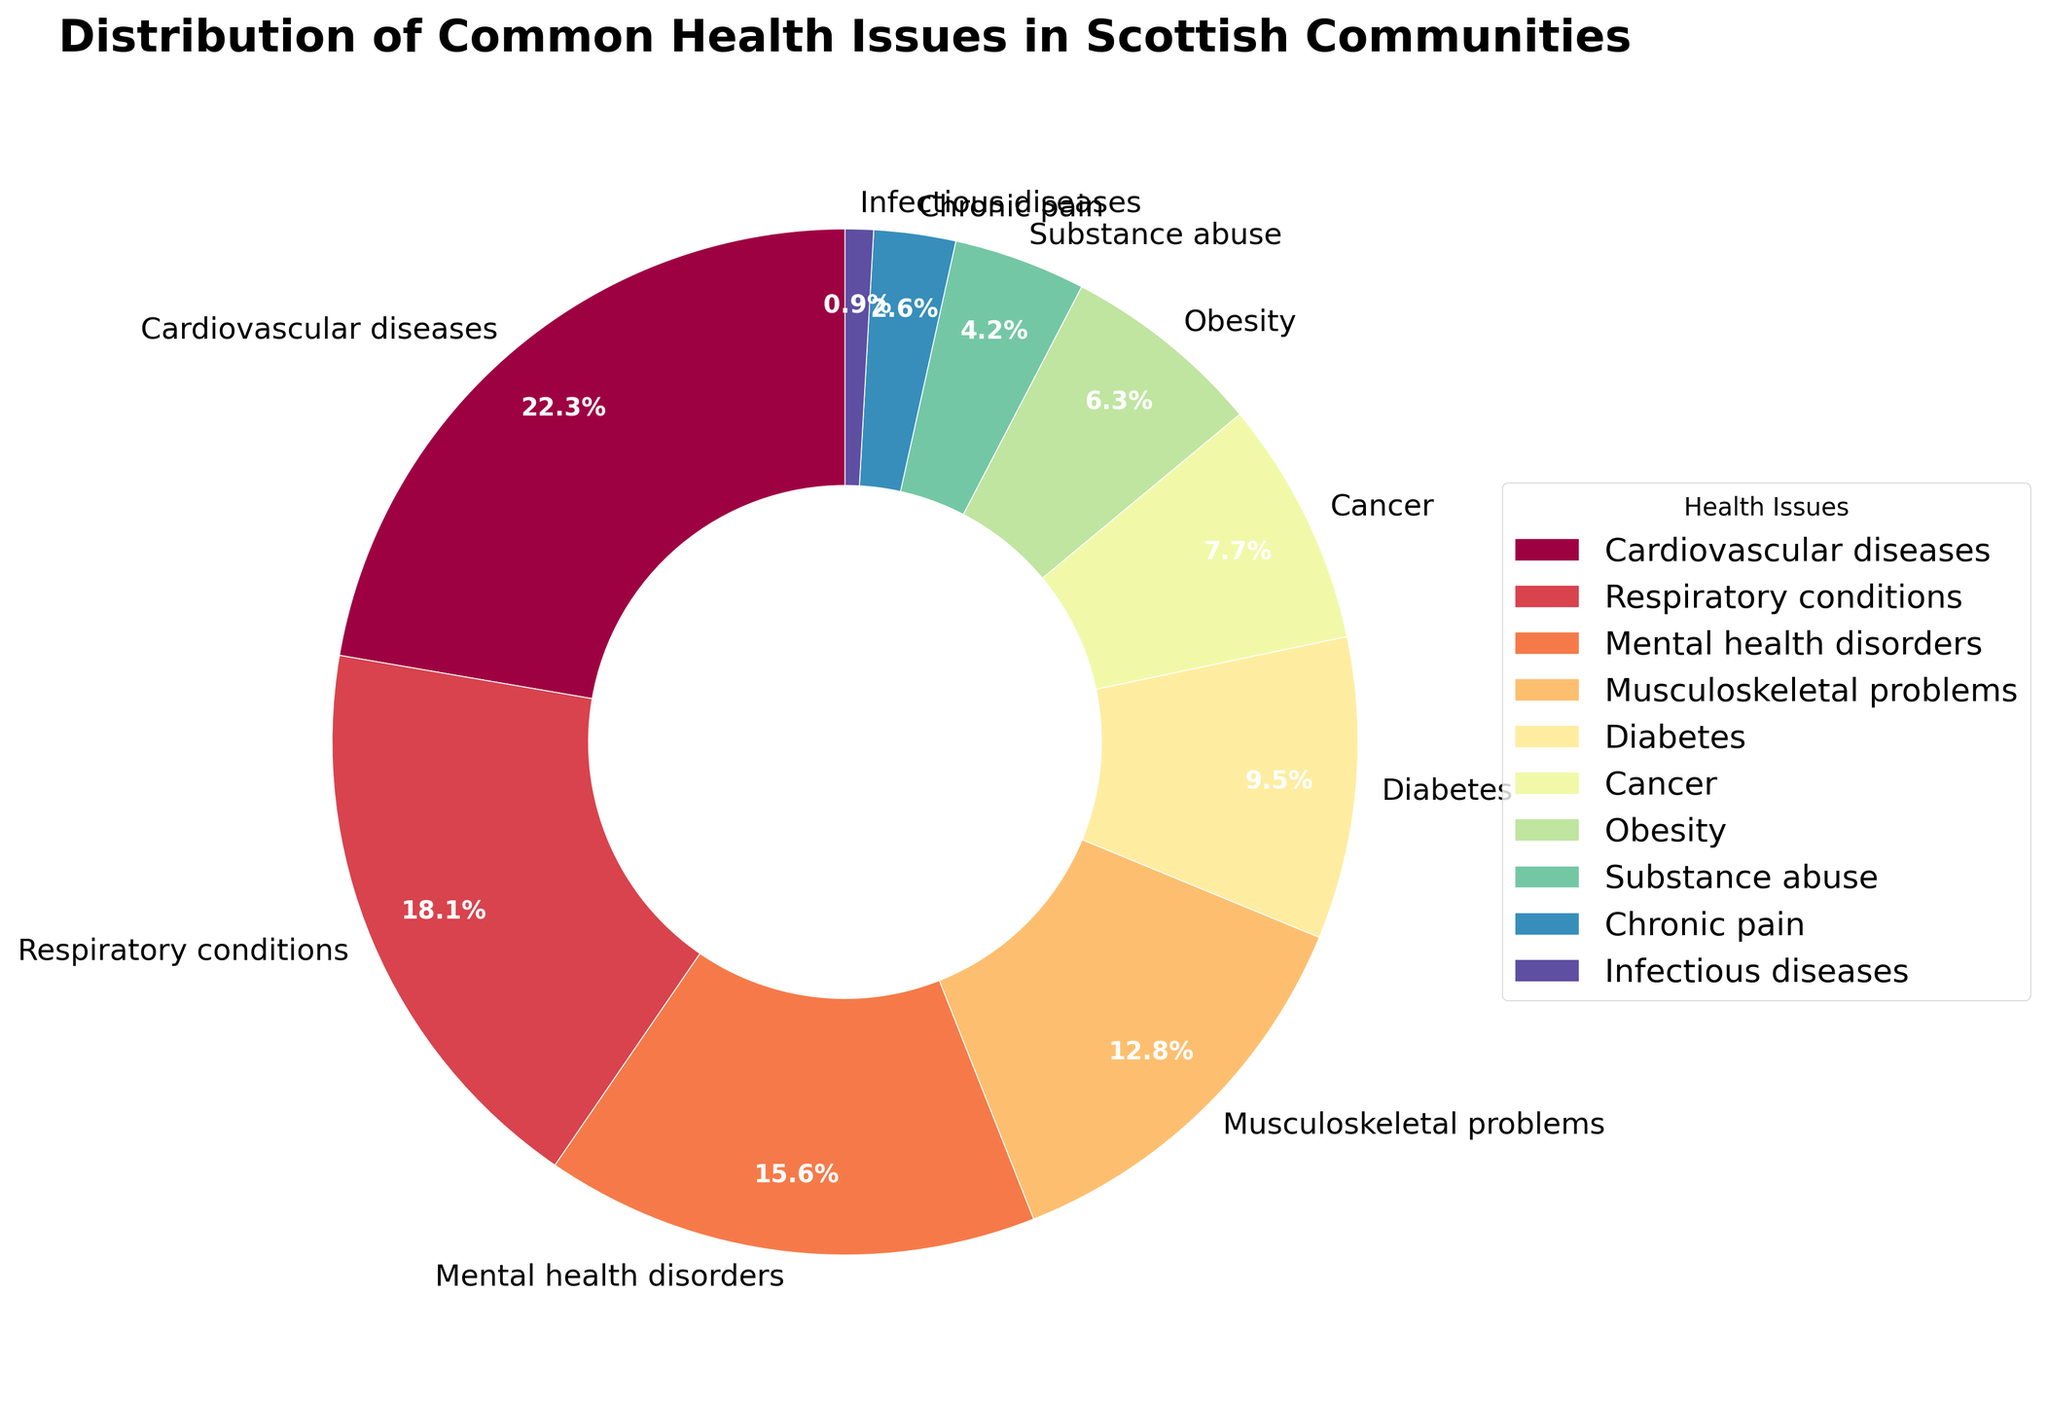Which health issue has the highest percentage? The chart categorizes health issues by their percentage distribution, where 'Cardiovascular diseases' has the highest percentage of 22.5%.
Answer: Cardiovascular diseases What is the combined percentage of chronic pain and infectious diseases? To find the combined percentage, add the percentages of 'Chronic pain' and 'Infectious diseases': 2.6% + 0.9% = 3.5%.
Answer: 3.5% Which health issue is represented by the smallest wedge of the pie chart? The visual size of the wedges in the pie chart corresponds to percentages, and 'Infectious diseases' has the smallest wedge, with a percentage of 0.9%.
Answer: Infectious diseases How many health issues have a percentage greater than 10%? The pie chart shows the percentages for each health issue. Count the categories where percentages exceed 10%: 'Cardiovascular diseases', 'Respiratory conditions', 'Mental health disorders', 'Musculoskeletal problems'. There are 4 such categories.
Answer: 4 What is the difference in percentage between obesity and diabetes? Subtract the percentage of 'Obesity' from 'Diabetes': 9.6% - 6.4% = 3.2%.
Answer: 3.2% Which health issues have a percentage difference of exactly 2.6%? Compare the percentages of the health issues to find pairs with a difference of 2.6%. 'Chronic pain' (2.6%) and 'Substance abuse' (4.2%) have a difference of 1.6%, but 'Musculoskeletal problems' (12.9%) and 'Mental health disorders' (15.7%) differ by exactly 2.8%. Thus, no pairs match exactly 2.6%.
Answer: None Is the percentage of cancer greater than that of obesity? Compare the percentages of 'Cancer' and 'Obesity': 7.8% (Cancer) is greater than 6.4% (Obesity).
Answer: Yes What is the total percentage of respiratory conditions, mental health disorders, and musculoskeletal problems combined? Add the percentages of the three categories: 18.3% (Respiratory conditions) + 15.7% (Mental health disorders) + 12.9% (Musculoskeletal problems) = 46.9%.
Answer: 46.9% Which health issue is represented in the central region of the color spectrum on the pie chart? The colors in the pie chart range from light to dark via a gradient. Observing this, 'Musculoskeletal problems' shows up in mid-spectrum color due to its central location in the percentage range (12.9%).
Answer: Musculoskeletal problems 